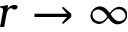Convert formula to latex. <formula><loc_0><loc_0><loc_500><loc_500>r \to \infty</formula> 